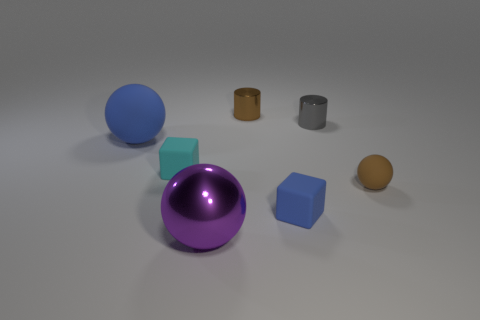Add 3 blue balls. How many objects exist? 10 Subtract all cylinders. How many objects are left? 5 Add 7 brown matte cylinders. How many brown matte cylinders exist? 7 Subtract 1 brown cylinders. How many objects are left? 6 Subtract all green matte blocks. Subtract all brown shiny objects. How many objects are left? 6 Add 7 purple shiny balls. How many purple shiny balls are left? 8 